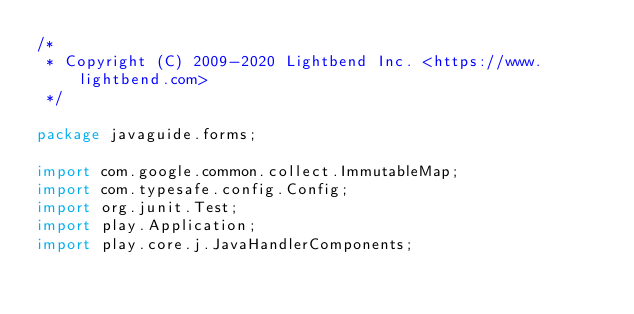<code> <loc_0><loc_0><loc_500><loc_500><_Java_>/*
 * Copyright (C) 2009-2020 Lightbend Inc. <https://www.lightbend.com>
 */

package javaguide.forms;

import com.google.common.collect.ImmutableMap;
import com.typesafe.config.Config;
import org.junit.Test;
import play.Application;
import play.core.j.JavaHandlerComponents;</code> 